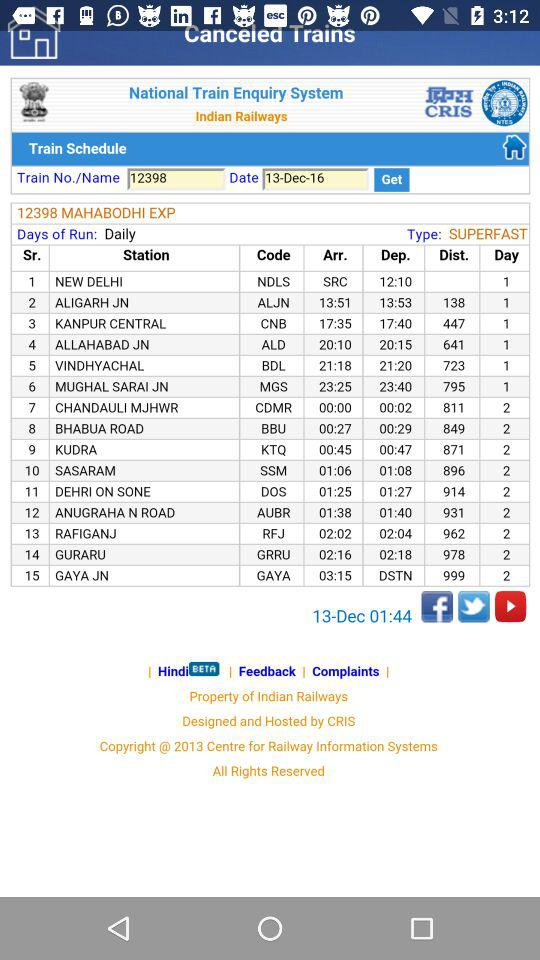What is the train name? The train name is "MAHABODHI EXP". 